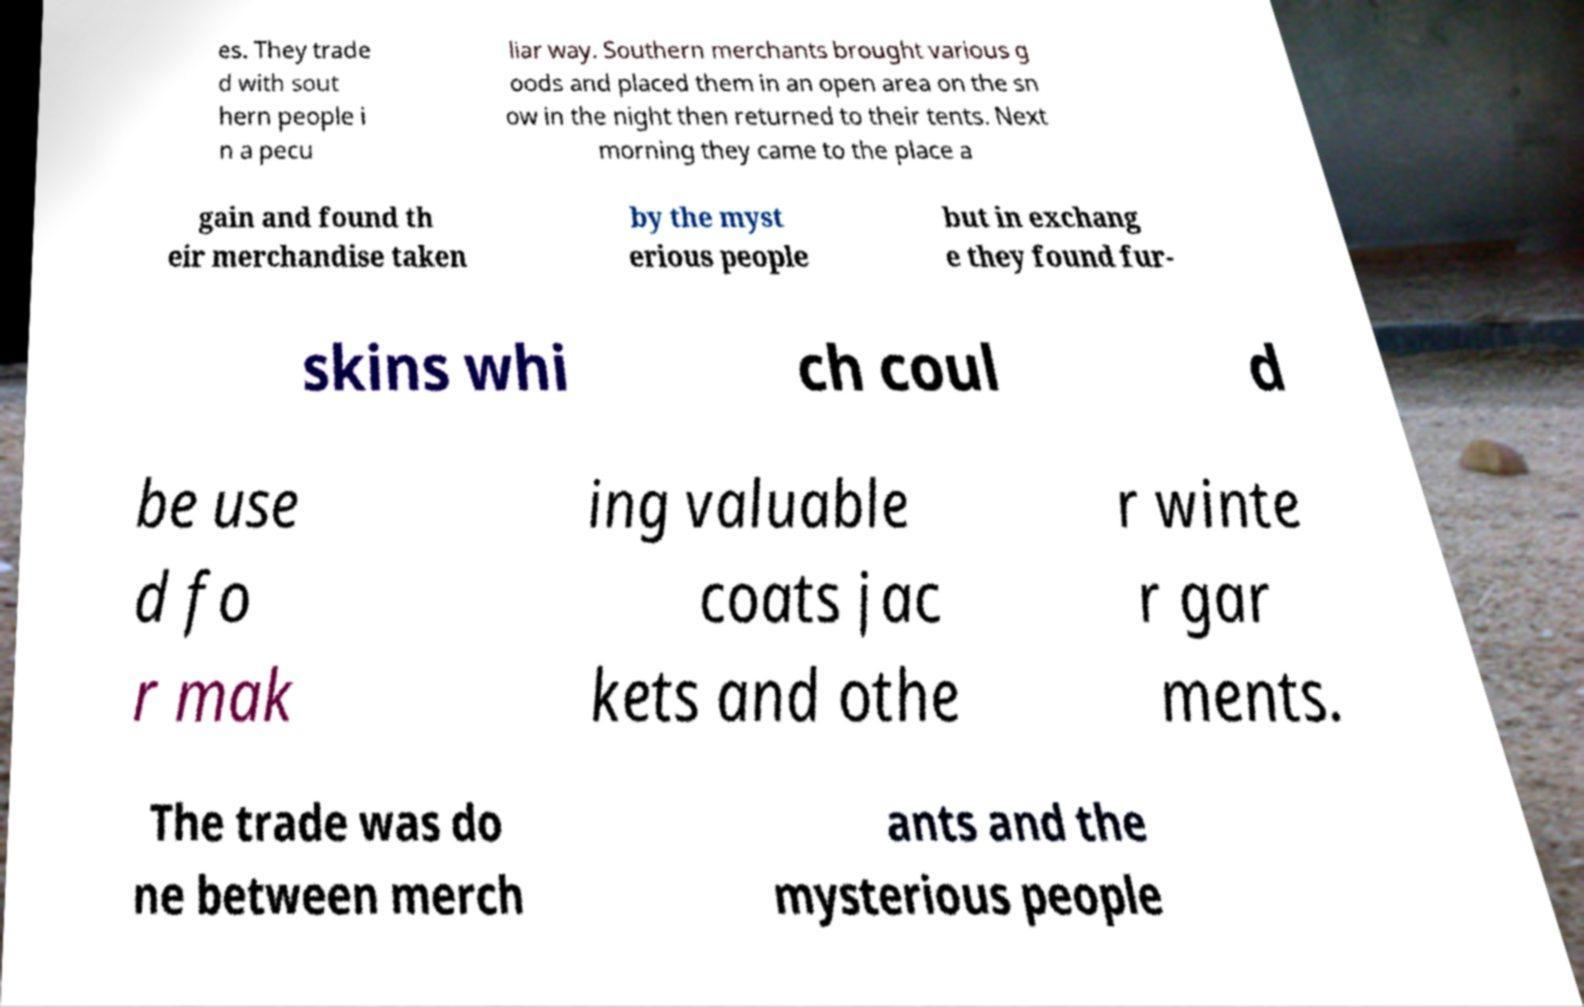Could you extract and type out the text from this image? es. They trade d with sout hern people i n a pecu liar way. Southern merchants brought various g oods and placed them in an open area on the sn ow in the night then returned to their tents. Next morning they came to the place a gain and found th eir merchandise taken by the myst erious people but in exchang e they found fur- skins whi ch coul d be use d fo r mak ing valuable coats jac kets and othe r winte r gar ments. The trade was do ne between merch ants and the mysterious people 